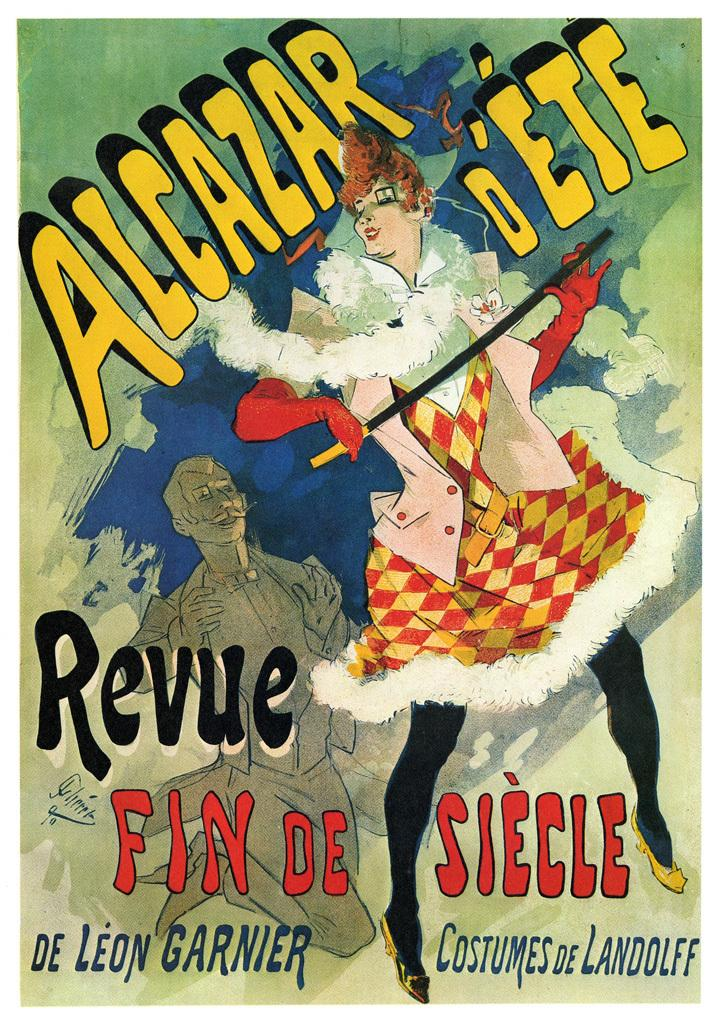<image>
Relay a brief, clear account of the picture shown. A poster that says Alcazar d'ete revue fin de siecle. 